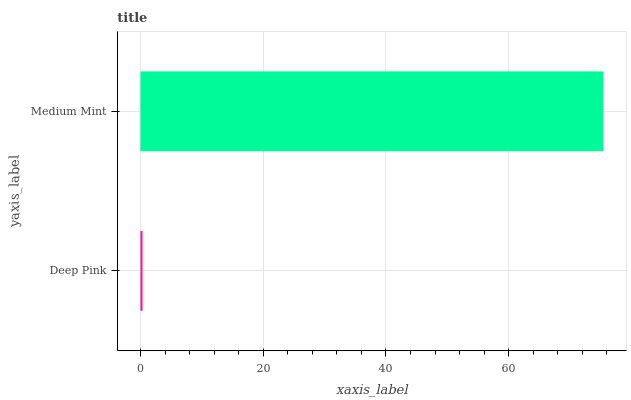Is Deep Pink the minimum?
Answer yes or no. Yes. Is Medium Mint the maximum?
Answer yes or no. Yes. Is Medium Mint the minimum?
Answer yes or no. No. Is Medium Mint greater than Deep Pink?
Answer yes or no. Yes. Is Deep Pink less than Medium Mint?
Answer yes or no. Yes. Is Deep Pink greater than Medium Mint?
Answer yes or no. No. Is Medium Mint less than Deep Pink?
Answer yes or no. No. Is Medium Mint the high median?
Answer yes or no. Yes. Is Deep Pink the low median?
Answer yes or no. Yes. Is Deep Pink the high median?
Answer yes or no. No. Is Medium Mint the low median?
Answer yes or no. No. 